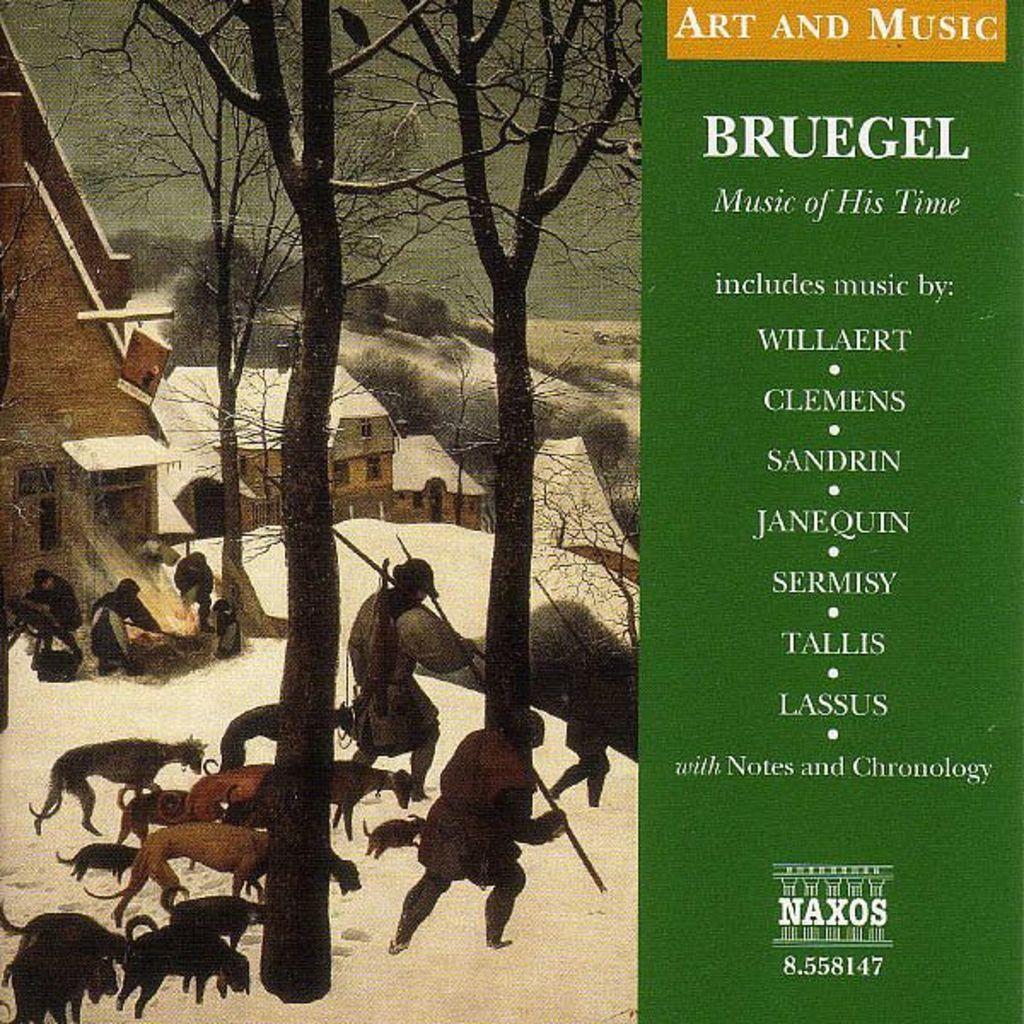Describe this image in one or two sentences. In this image I can see a poster on which we can see there is a painting of buildings, trees, animals and person on the snow, beside that there is some text. 